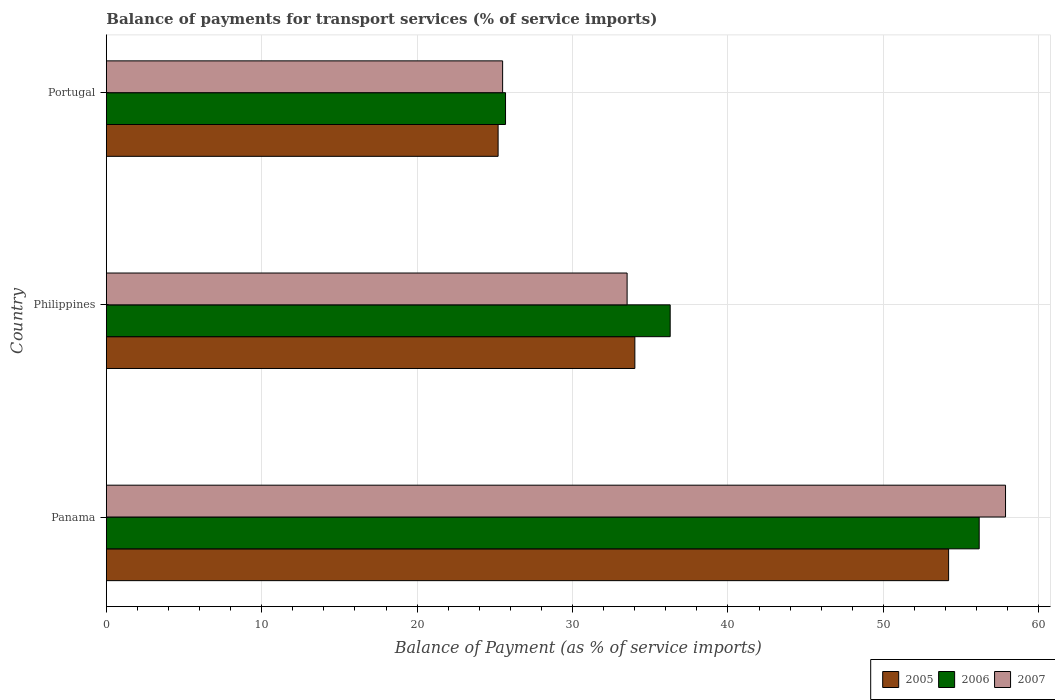How many bars are there on the 3rd tick from the top?
Offer a very short reply. 3. In how many cases, is the number of bars for a given country not equal to the number of legend labels?
Your answer should be very brief. 0. What is the balance of payments for transport services in 2006 in Panama?
Your response must be concise. 56.17. Across all countries, what is the maximum balance of payments for transport services in 2006?
Your response must be concise. 56.17. Across all countries, what is the minimum balance of payments for transport services in 2007?
Provide a short and direct response. 25.5. In which country was the balance of payments for transport services in 2005 maximum?
Your response must be concise. Panama. In which country was the balance of payments for transport services in 2007 minimum?
Your answer should be very brief. Portugal. What is the total balance of payments for transport services in 2006 in the graph?
Give a very brief answer. 118.14. What is the difference between the balance of payments for transport services in 2005 in Panama and that in Portugal?
Offer a very short reply. 28.99. What is the difference between the balance of payments for transport services in 2007 in Philippines and the balance of payments for transport services in 2006 in Portugal?
Offer a terse response. 7.82. What is the average balance of payments for transport services in 2006 per country?
Your answer should be compact. 39.38. What is the difference between the balance of payments for transport services in 2005 and balance of payments for transport services in 2007 in Portugal?
Keep it short and to the point. -0.29. In how many countries, is the balance of payments for transport services in 2007 greater than 12 %?
Ensure brevity in your answer.  3. What is the ratio of the balance of payments for transport services in 2005 in Philippines to that in Portugal?
Keep it short and to the point. 1.35. Is the balance of payments for transport services in 2007 in Philippines less than that in Portugal?
Offer a very short reply. No. What is the difference between the highest and the second highest balance of payments for transport services in 2006?
Provide a short and direct response. 19.88. What is the difference between the highest and the lowest balance of payments for transport services in 2005?
Ensure brevity in your answer.  28.99. In how many countries, is the balance of payments for transport services in 2007 greater than the average balance of payments for transport services in 2007 taken over all countries?
Offer a terse response. 1. Is the sum of the balance of payments for transport services in 2006 in Panama and Philippines greater than the maximum balance of payments for transport services in 2007 across all countries?
Give a very brief answer. Yes. What does the 2nd bar from the top in Philippines represents?
Ensure brevity in your answer.  2006. Is it the case that in every country, the sum of the balance of payments for transport services in 2006 and balance of payments for transport services in 2007 is greater than the balance of payments for transport services in 2005?
Your answer should be very brief. Yes. Does the graph contain grids?
Provide a short and direct response. Yes. How are the legend labels stacked?
Give a very brief answer. Horizontal. What is the title of the graph?
Your answer should be compact. Balance of payments for transport services (% of service imports). What is the label or title of the X-axis?
Your answer should be compact. Balance of Payment (as % of service imports). What is the Balance of Payment (as % of service imports) in 2005 in Panama?
Keep it short and to the point. 54.2. What is the Balance of Payment (as % of service imports) in 2006 in Panama?
Your answer should be compact. 56.17. What is the Balance of Payment (as % of service imports) in 2007 in Panama?
Offer a very short reply. 57.86. What is the Balance of Payment (as % of service imports) in 2005 in Philippines?
Your answer should be very brief. 34.01. What is the Balance of Payment (as % of service imports) in 2006 in Philippines?
Your answer should be very brief. 36.28. What is the Balance of Payment (as % of service imports) in 2007 in Philippines?
Provide a succinct answer. 33.51. What is the Balance of Payment (as % of service imports) in 2005 in Portugal?
Give a very brief answer. 25.21. What is the Balance of Payment (as % of service imports) of 2006 in Portugal?
Offer a very short reply. 25.69. What is the Balance of Payment (as % of service imports) of 2007 in Portugal?
Your answer should be compact. 25.5. Across all countries, what is the maximum Balance of Payment (as % of service imports) of 2005?
Provide a short and direct response. 54.2. Across all countries, what is the maximum Balance of Payment (as % of service imports) of 2006?
Give a very brief answer. 56.17. Across all countries, what is the maximum Balance of Payment (as % of service imports) in 2007?
Ensure brevity in your answer.  57.86. Across all countries, what is the minimum Balance of Payment (as % of service imports) of 2005?
Offer a very short reply. 25.21. Across all countries, what is the minimum Balance of Payment (as % of service imports) in 2006?
Make the answer very short. 25.69. Across all countries, what is the minimum Balance of Payment (as % of service imports) of 2007?
Your answer should be very brief. 25.5. What is the total Balance of Payment (as % of service imports) in 2005 in the graph?
Keep it short and to the point. 113.42. What is the total Balance of Payment (as % of service imports) of 2006 in the graph?
Provide a succinct answer. 118.14. What is the total Balance of Payment (as % of service imports) of 2007 in the graph?
Provide a short and direct response. 116.88. What is the difference between the Balance of Payment (as % of service imports) of 2005 in Panama and that in Philippines?
Give a very brief answer. 20.19. What is the difference between the Balance of Payment (as % of service imports) in 2006 in Panama and that in Philippines?
Your answer should be very brief. 19.88. What is the difference between the Balance of Payment (as % of service imports) in 2007 in Panama and that in Philippines?
Offer a very short reply. 24.35. What is the difference between the Balance of Payment (as % of service imports) in 2005 in Panama and that in Portugal?
Provide a succinct answer. 28.99. What is the difference between the Balance of Payment (as % of service imports) in 2006 in Panama and that in Portugal?
Make the answer very short. 30.48. What is the difference between the Balance of Payment (as % of service imports) in 2007 in Panama and that in Portugal?
Your answer should be very brief. 32.36. What is the difference between the Balance of Payment (as % of service imports) of 2006 in Philippines and that in Portugal?
Offer a terse response. 10.6. What is the difference between the Balance of Payment (as % of service imports) in 2007 in Philippines and that in Portugal?
Make the answer very short. 8.01. What is the difference between the Balance of Payment (as % of service imports) of 2005 in Panama and the Balance of Payment (as % of service imports) of 2006 in Philippines?
Give a very brief answer. 17.92. What is the difference between the Balance of Payment (as % of service imports) of 2005 in Panama and the Balance of Payment (as % of service imports) of 2007 in Philippines?
Your response must be concise. 20.69. What is the difference between the Balance of Payment (as % of service imports) of 2006 in Panama and the Balance of Payment (as % of service imports) of 2007 in Philippines?
Give a very brief answer. 22.66. What is the difference between the Balance of Payment (as % of service imports) in 2005 in Panama and the Balance of Payment (as % of service imports) in 2006 in Portugal?
Keep it short and to the point. 28.51. What is the difference between the Balance of Payment (as % of service imports) in 2005 in Panama and the Balance of Payment (as % of service imports) in 2007 in Portugal?
Give a very brief answer. 28.7. What is the difference between the Balance of Payment (as % of service imports) in 2006 in Panama and the Balance of Payment (as % of service imports) in 2007 in Portugal?
Offer a terse response. 30.67. What is the difference between the Balance of Payment (as % of service imports) of 2005 in Philippines and the Balance of Payment (as % of service imports) of 2006 in Portugal?
Ensure brevity in your answer.  8.32. What is the difference between the Balance of Payment (as % of service imports) of 2005 in Philippines and the Balance of Payment (as % of service imports) of 2007 in Portugal?
Make the answer very short. 8.51. What is the difference between the Balance of Payment (as % of service imports) of 2006 in Philippines and the Balance of Payment (as % of service imports) of 2007 in Portugal?
Your answer should be compact. 10.78. What is the average Balance of Payment (as % of service imports) of 2005 per country?
Your answer should be compact. 37.81. What is the average Balance of Payment (as % of service imports) in 2006 per country?
Offer a very short reply. 39.38. What is the average Balance of Payment (as % of service imports) in 2007 per country?
Offer a terse response. 38.96. What is the difference between the Balance of Payment (as % of service imports) in 2005 and Balance of Payment (as % of service imports) in 2006 in Panama?
Provide a succinct answer. -1.97. What is the difference between the Balance of Payment (as % of service imports) of 2005 and Balance of Payment (as % of service imports) of 2007 in Panama?
Offer a very short reply. -3.66. What is the difference between the Balance of Payment (as % of service imports) of 2006 and Balance of Payment (as % of service imports) of 2007 in Panama?
Offer a terse response. -1.7. What is the difference between the Balance of Payment (as % of service imports) in 2005 and Balance of Payment (as % of service imports) in 2006 in Philippines?
Offer a terse response. -2.27. What is the difference between the Balance of Payment (as % of service imports) of 2005 and Balance of Payment (as % of service imports) of 2007 in Philippines?
Provide a short and direct response. 0.5. What is the difference between the Balance of Payment (as % of service imports) in 2006 and Balance of Payment (as % of service imports) in 2007 in Philippines?
Your response must be concise. 2.77. What is the difference between the Balance of Payment (as % of service imports) in 2005 and Balance of Payment (as % of service imports) in 2006 in Portugal?
Provide a succinct answer. -0.48. What is the difference between the Balance of Payment (as % of service imports) in 2005 and Balance of Payment (as % of service imports) in 2007 in Portugal?
Give a very brief answer. -0.29. What is the difference between the Balance of Payment (as % of service imports) in 2006 and Balance of Payment (as % of service imports) in 2007 in Portugal?
Make the answer very short. 0.19. What is the ratio of the Balance of Payment (as % of service imports) of 2005 in Panama to that in Philippines?
Your answer should be compact. 1.59. What is the ratio of the Balance of Payment (as % of service imports) in 2006 in Panama to that in Philippines?
Make the answer very short. 1.55. What is the ratio of the Balance of Payment (as % of service imports) of 2007 in Panama to that in Philippines?
Your answer should be very brief. 1.73. What is the ratio of the Balance of Payment (as % of service imports) of 2005 in Panama to that in Portugal?
Keep it short and to the point. 2.15. What is the ratio of the Balance of Payment (as % of service imports) of 2006 in Panama to that in Portugal?
Offer a terse response. 2.19. What is the ratio of the Balance of Payment (as % of service imports) in 2007 in Panama to that in Portugal?
Provide a short and direct response. 2.27. What is the ratio of the Balance of Payment (as % of service imports) of 2005 in Philippines to that in Portugal?
Keep it short and to the point. 1.35. What is the ratio of the Balance of Payment (as % of service imports) of 2006 in Philippines to that in Portugal?
Provide a succinct answer. 1.41. What is the ratio of the Balance of Payment (as % of service imports) of 2007 in Philippines to that in Portugal?
Ensure brevity in your answer.  1.31. What is the difference between the highest and the second highest Balance of Payment (as % of service imports) in 2005?
Offer a very short reply. 20.19. What is the difference between the highest and the second highest Balance of Payment (as % of service imports) in 2006?
Keep it short and to the point. 19.88. What is the difference between the highest and the second highest Balance of Payment (as % of service imports) of 2007?
Your answer should be compact. 24.35. What is the difference between the highest and the lowest Balance of Payment (as % of service imports) of 2005?
Provide a short and direct response. 28.99. What is the difference between the highest and the lowest Balance of Payment (as % of service imports) of 2006?
Your answer should be very brief. 30.48. What is the difference between the highest and the lowest Balance of Payment (as % of service imports) in 2007?
Ensure brevity in your answer.  32.36. 